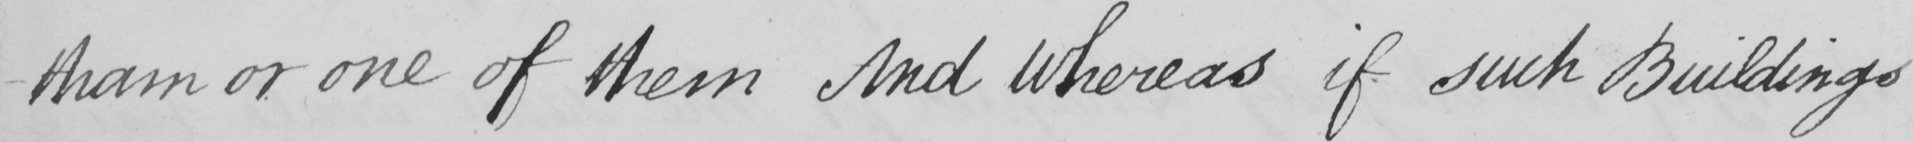Transcribe the text shown in this historical manuscript line. -tham or one of them And Whereas if such buildings 